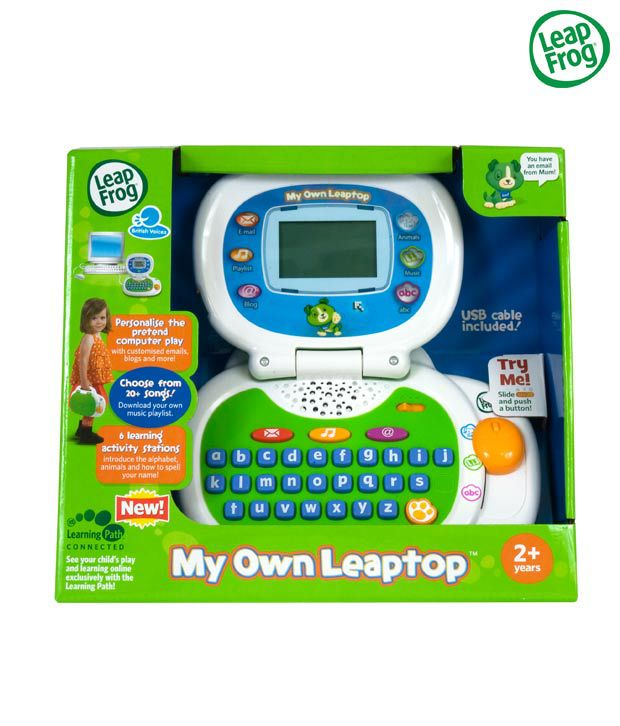How might the inclusion of a USB cable contribute to the interactive experience offered by this toy? The inclusion of a USB cable significantly enhances the toy's interactivity and educational potential. By allowing it to connect to a computer, it opens up possibilities for content updates, such as downloading new educational games and songs. Furthermore, it could enable connection to online platforms, potentially allowing parents to track their child’s educational progress and set personalized learning paths. These features make the learning experience more dynamic, tailored, and engaging for the child, continuously renewing the toy’s appeal and educational value. 